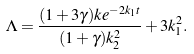<formula> <loc_0><loc_0><loc_500><loc_500>\Lambda = \frac { ( 1 + 3 \gamma ) k e ^ { - 2 k _ { 1 } t } } { ( 1 + \gamma ) k _ { 2 } ^ { 2 } } + 3 k _ { 1 } ^ { 2 } .</formula> 